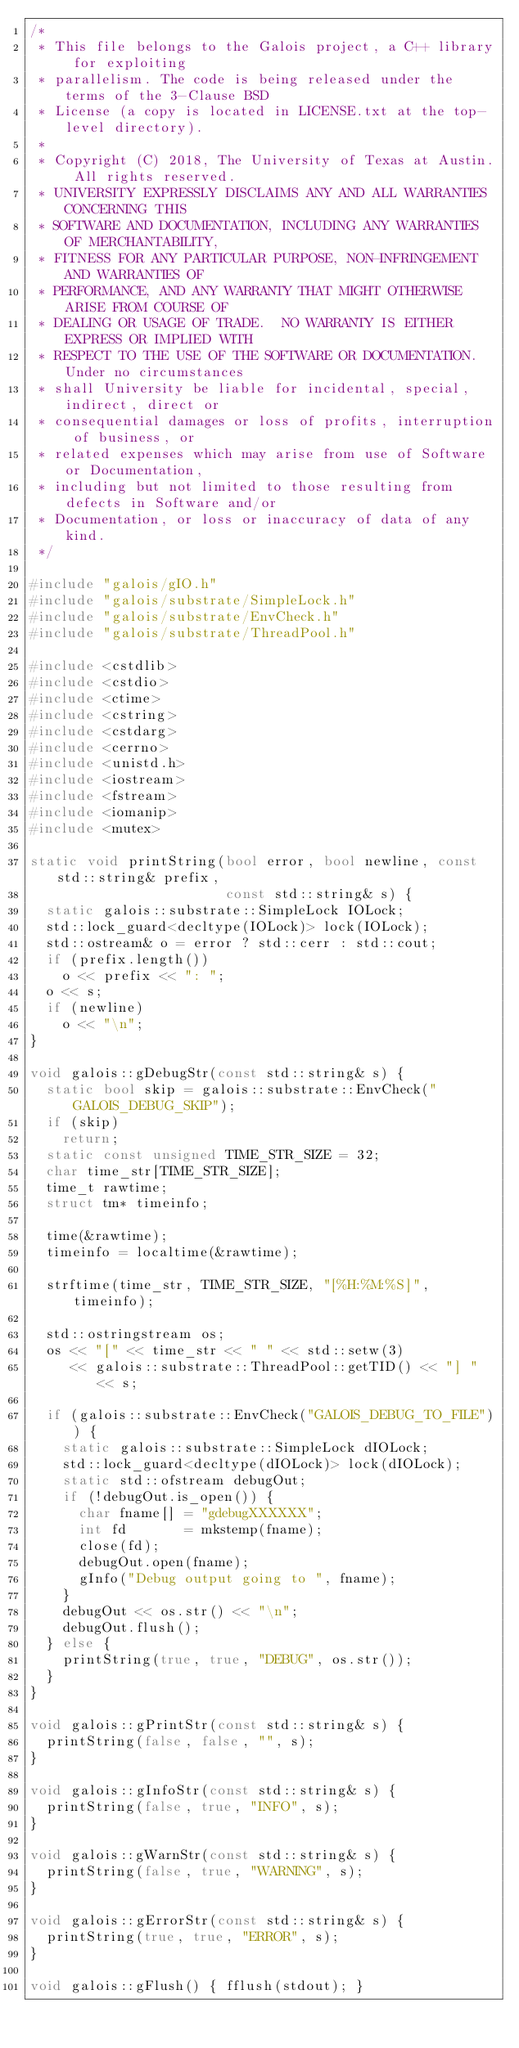Convert code to text. <code><loc_0><loc_0><loc_500><loc_500><_C++_>/*
 * This file belongs to the Galois project, a C++ library for exploiting
 * parallelism. The code is being released under the terms of the 3-Clause BSD
 * License (a copy is located in LICENSE.txt at the top-level directory).
 *
 * Copyright (C) 2018, The University of Texas at Austin. All rights reserved.
 * UNIVERSITY EXPRESSLY DISCLAIMS ANY AND ALL WARRANTIES CONCERNING THIS
 * SOFTWARE AND DOCUMENTATION, INCLUDING ANY WARRANTIES OF MERCHANTABILITY,
 * FITNESS FOR ANY PARTICULAR PURPOSE, NON-INFRINGEMENT AND WARRANTIES OF
 * PERFORMANCE, AND ANY WARRANTY THAT MIGHT OTHERWISE ARISE FROM COURSE OF
 * DEALING OR USAGE OF TRADE.  NO WARRANTY IS EITHER EXPRESS OR IMPLIED WITH
 * RESPECT TO THE USE OF THE SOFTWARE OR DOCUMENTATION. Under no circumstances
 * shall University be liable for incidental, special, indirect, direct or
 * consequential damages or loss of profits, interruption of business, or
 * related expenses which may arise from use of Software or Documentation,
 * including but not limited to those resulting from defects in Software and/or
 * Documentation, or loss or inaccuracy of data of any kind.
 */

#include "galois/gIO.h"
#include "galois/substrate/SimpleLock.h"
#include "galois/substrate/EnvCheck.h"
#include "galois/substrate/ThreadPool.h"

#include <cstdlib>
#include <cstdio>
#include <ctime>
#include <cstring>
#include <cstdarg>
#include <cerrno>
#include <unistd.h>
#include <iostream>
#include <fstream>
#include <iomanip>
#include <mutex>

static void printString(bool error, bool newline, const std::string& prefix,
                        const std::string& s) {
  static galois::substrate::SimpleLock IOLock;
  std::lock_guard<decltype(IOLock)> lock(IOLock);
  std::ostream& o = error ? std::cerr : std::cout;
  if (prefix.length())
    o << prefix << ": ";
  o << s;
  if (newline)
    o << "\n";
}

void galois::gDebugStr(const std::string& s) {
  static bool skip = galois::substrate::EnvCheck("GALOIS_DEBUG_SKIP");
  if (skip)
    return;
  static const unsigned TIME_STR_SIZE = 32;
  char time_str[TIME_STR_SIZE];
  time_t rawtime;
  struct tm* timeinfo;

  time(&rawtime);
  timeinfo = localtime(&rawtime);

  strftime(time_str, TIME_STR_SIZE, "[%H:%M:%S]", timeinfo);

  std::ostringstream os;
  os << "[" << time_str << " " << std::setw(3)
     << galois::substrate::ThreadPool::getTID() << "] " << s;

  if (galois::substrate::EnvCheck("GALOIS_DEBUG_TO_FILE")) {
    static galois::substrate::SimpleLock dIOLock;
    std::lock_guard<decltype(dIOLock)> lock(dIOLock);
    static std::ofstream debugOut;
    if (!debugOut.is_open()) {
      char fname[] = "gdebugXXXXXX";
      int fd       = mkstemp(fname);
      close(fd);
      debugOut.open(fname);
      gInfo("Debug output going to ", fname);
    }
    debugOut << os.str() << "\n";
    debugOut.flush();
  } else {
    printString(true, true, "DEBUG", os.str());
  }
}

void galois::gPrintStr(const std::string& s) {
  printString(false, false, "", s);
}

void galois::gInfoStr(const std::string& s) {
  printString(false, true, "INFO", s);
}

void galois::gWarnStr(const std::string& s) {
  printString(false, true, "WARNING", s);
}

void galois::gErrorStr(const std::string& s) {
  printString(true, true, "ERROR", s);
}

void galois::gFlush() { fflush(stdout); }
</code> 